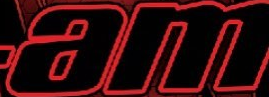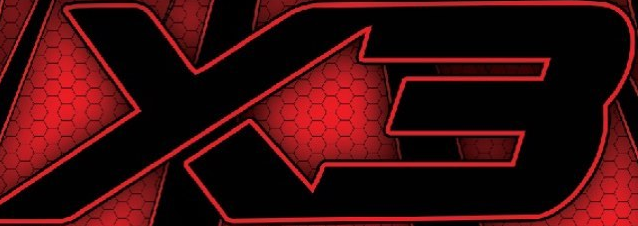Identify the words shown in these images in order, separated by a semicolon. am; X3 